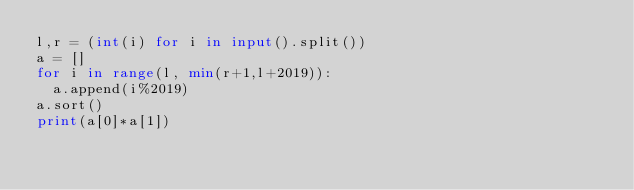Convert code to text. <code><loc_0><loc_0><loc_500><loc_500><_Python_>l,r = (int(i) for i in input().split())
a = []
for i in range(l, min(r+1,l+2019)):
  a.append(i%2019)
a.sort()
print(a[0]*a[1])</code> 